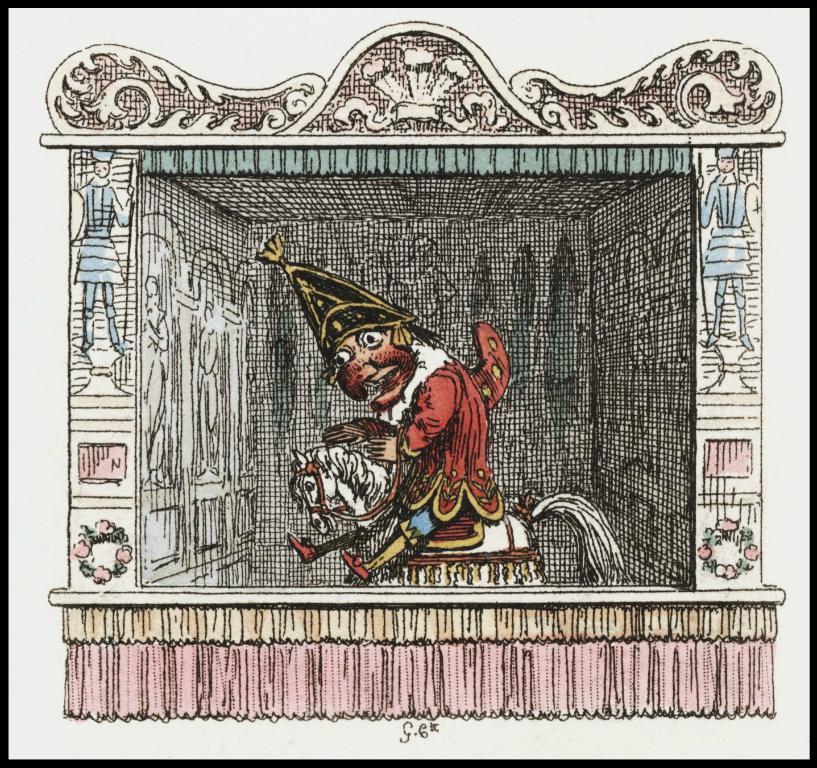In one or two sentences, can you explain what this image depicts? In this image I can see the art in which I can see the cartoon person is sitting on the horse. I can see few cartoon pictures, designs and few flowers on the wall. 